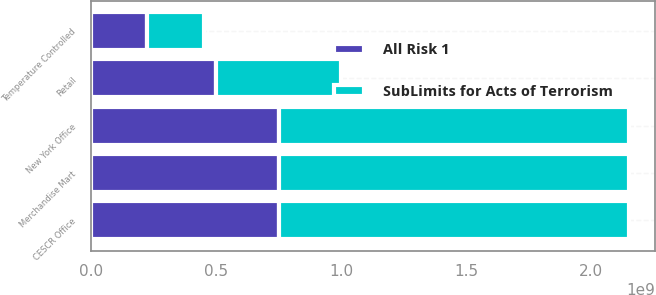Convert chart. <chart><loc_0><loc_0><loc_500><loc_500><stacked_bar_chart><ecel><fcel>New York Office<fcel>CESCR Office<fcel>Retail<fcel>Merchandise Mart<fcel>Temperature Controlled<nl><fcel>SubLimits for Acts of Terrorism<fcel>1.4e+09<fcel>1.4e+09<fcel>5e+08<fcel>1.4e+09<fcel>2.25e+08<nl><fcel>All Risk 1<fcel>7.5e+08<fcel>7.5e+08<fcel>5e+08<fcel>7.5e+08<fcel>2.25e+08<nl></chart> 